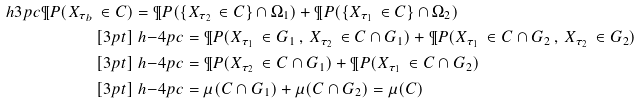Convert formula to latex. <formula><loc_0><loc_0><loc_500><loc_500>\ h { 3 p c } \P P ( X _ { \tau _ { b } } \, \in C ) & = \P P ( \{ X _ { \tau _ { 2 } } \, \in C \} \cap \Omega _ { 1 } ) + \P P ( \{ X _ { \tau _ { 1 } } \, \in C \} \cap \Omega _ { 2 } ) \\ [ 3 p t ] & \ h { - 4 p c } = \P P ( X _ { \tau _ { 1 } } \, \in G _ { 1 } \, , \, X _ { \tau _ { 2 } } \, \in C \cap G _ { 1 } ) + \P P ( X _ { \tau _ { 1 } } \, \in C \cap G _ { 2 } \, , \, X _ { \tau _ { 2 } } \, \in G _ { 2 } ) \\ [ 3 p t ] & \ h { - 4 p c } = \P P ( X _ { \tau _ { 2 } } \, \in C \cap G _ { 1 } ) + \P P ( X _ { \tau _ { 1 } } \, \in C \cap G _ { 2 } ) \\ [ 3 p t ] & \ h { - 4 p c } = \mu ( C \cap G _ { 1 } ) + \mu ( C \cap G _ { 2 } ) = \mu ( C )</formula> 